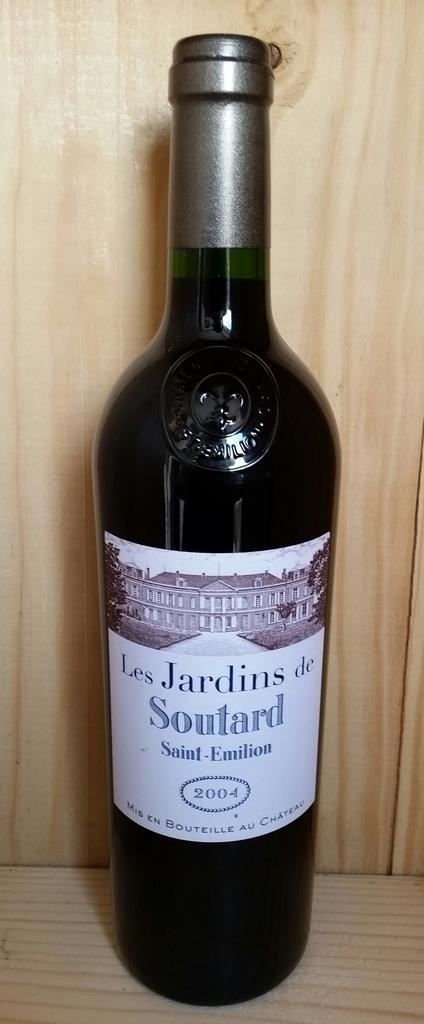<image>
Offer a succinct explanation of the picture presented. A bottle of wine from 2004 sits in a wooden crate. 